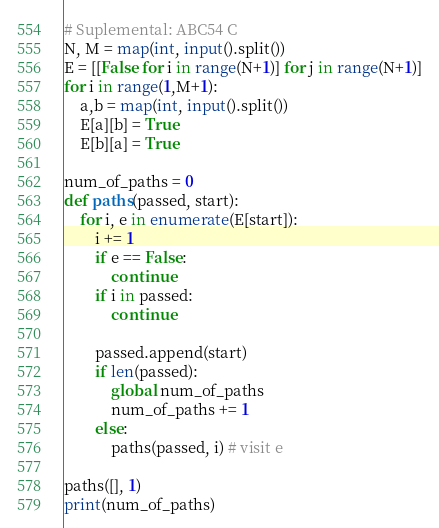<code> <loc_0><loc_0><loc_500><loc_500><_Python_># Suplemental: ABC54 C
N, M = map(int, input().split())
E = [[False for i in range(N+1)] for j in range(N+1)]
for i in range(1,M+1):
    a,b = map(int, input().split())
    E[a][b] = True
    E[b][a] = True
    
num_of_paths = 0
def paths(passed, start):
    for i, e in enumerate(E[start]):
        i += 1
        if e == False:
            continue
        if i in passed:
            continue
        
        passed.append(start)
        if len(passed):
            global num_of_paths
            num_of_paths += 1
        else:
            paths(passed, i) # visit e
    
paths([], 1)
print(num_of_paths)</code> 